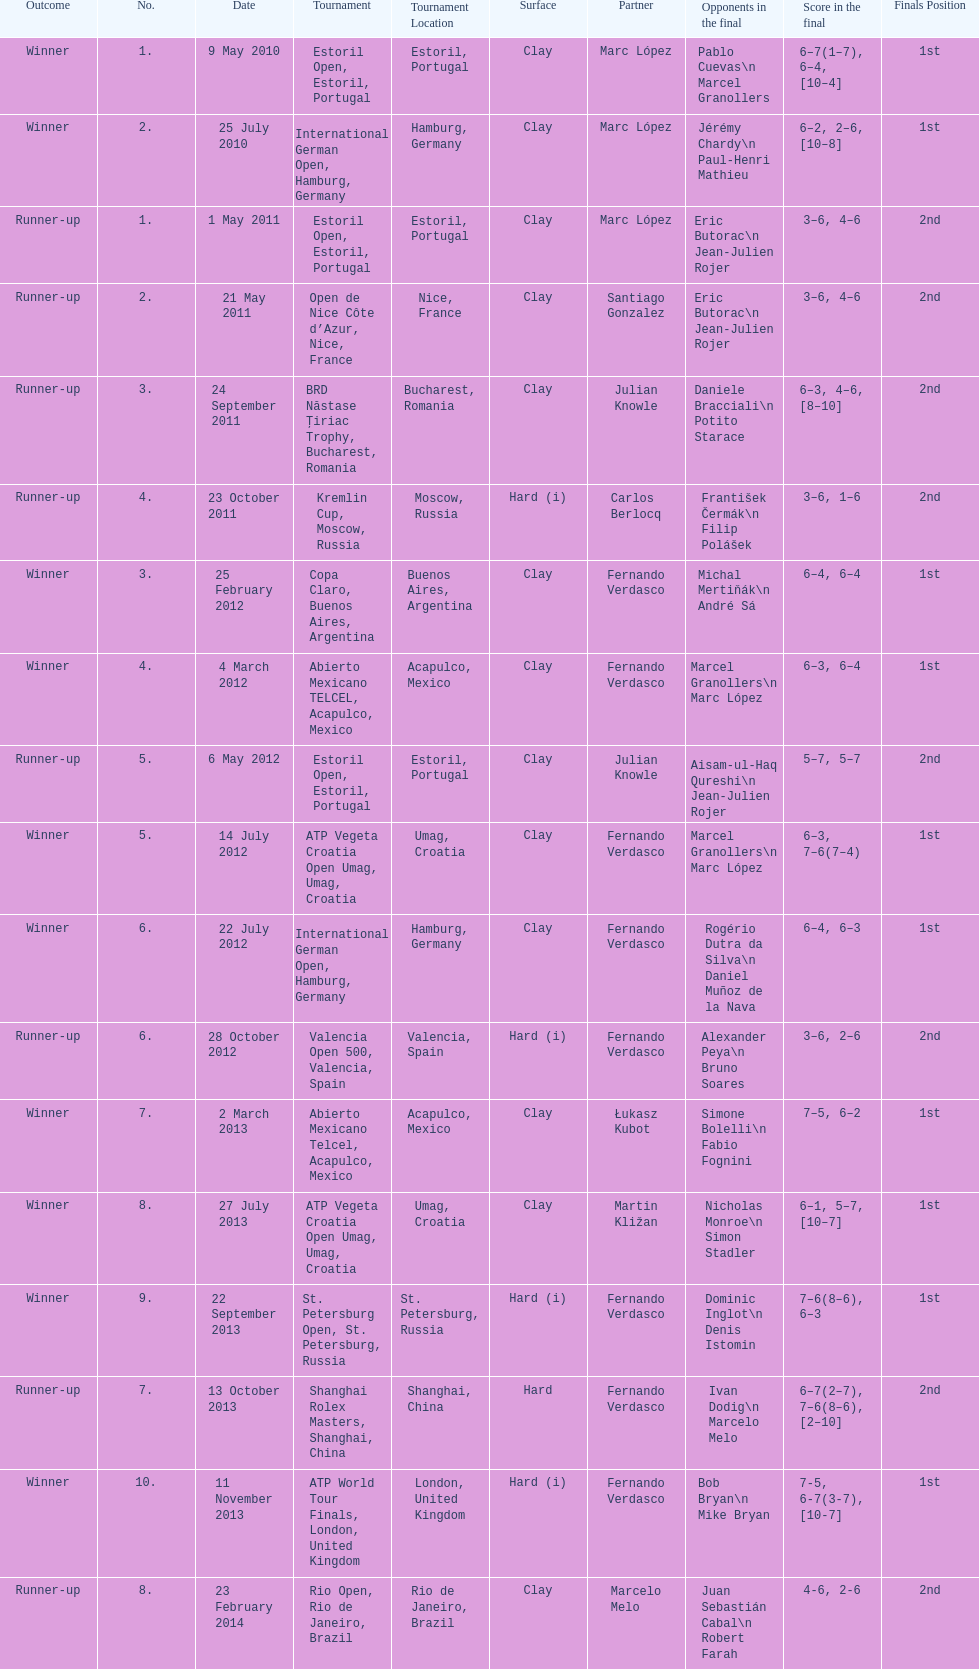Which tournament has the largest number? ATP World Tour Finals. 